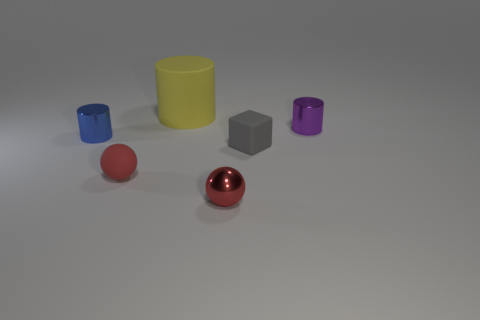Subtract all tiny blue cylinders. How many cylinders are left? 2 Add 4 big purple metal objects. How many objects exist? 10 Subtract all purple cylinders. How many cylinders are left? 2 Subtract all balls. How many objects are left? 4 Subtract 1 cylinders. How many cylinders are left? 2 Subtract all green cylinders. Subtract all blue spheres. How many cylinders are left? 3 Subtract all big matte cylinders. Subtract all large blue things. How many objects are left? 5 Add 1 red shiny things. How many red shiny things are left? 2 Add 5 tiny matte spheres. How many tiny matte spheres exist? 6 Subtract 0 brown cylinders. How many objects are left? 6 